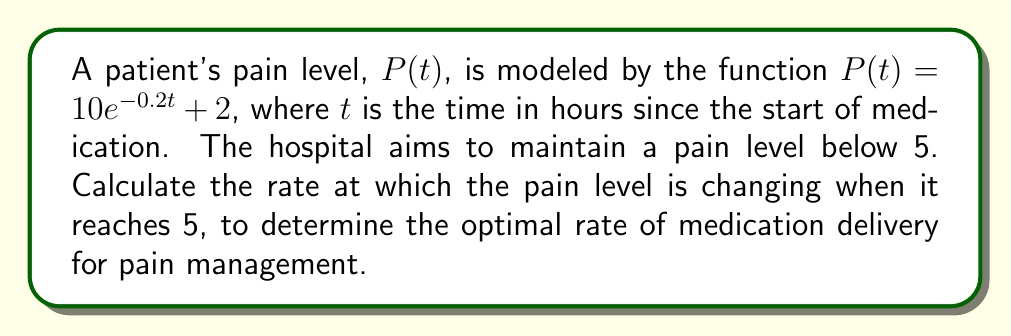Give your solution to this math problem. 1) To find the rate of change of pain level, we need to calculate the derivative of $P(t)$:

   $$\frac{dP}{dt} = -2e^{-0.2t}$$

2) Now, we need to find the time $t$ when the pain level is 5:

   $$5 = 10e^{-0.2t} + 2$$
   $$3 = 10e^{-0.2t}$$
   $$0.3 = e^{-0.2t}$$
   $$\ln(0.3) = -0.2t$$
   $$t = -\frac{\ln(0.3)}{0.2} \approx 6.02 \text{ hours}$$

3) Now we can calculate the rate of change at this time:

   $$\frac{dP}{dt}\bigg|_{t=6.02} = -2e^{-0.2(6.02)} \approx -0.6$$

4) The negative value indicates that the pain level is decreasing. The rate of decrease is approximately 0.6 units per hour when the pain level reaches 5.
Answer: $-0.6$ units/hour 